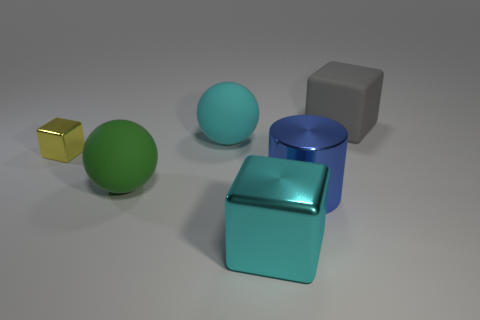Add 1 rubber blocks. How many objects exist? 7 Subtract all cylinders. How many objects are left? 5 Subtract 1 cyan blocks. How many objects are left? 5 Subtract all big brown rubber cylinders. Subtract all blue objects. How many objects are left? 5 Add 1 big green objects. How many big green objects are left? 2 Add 1 large green matte things. How many large green matte things exist? 2 